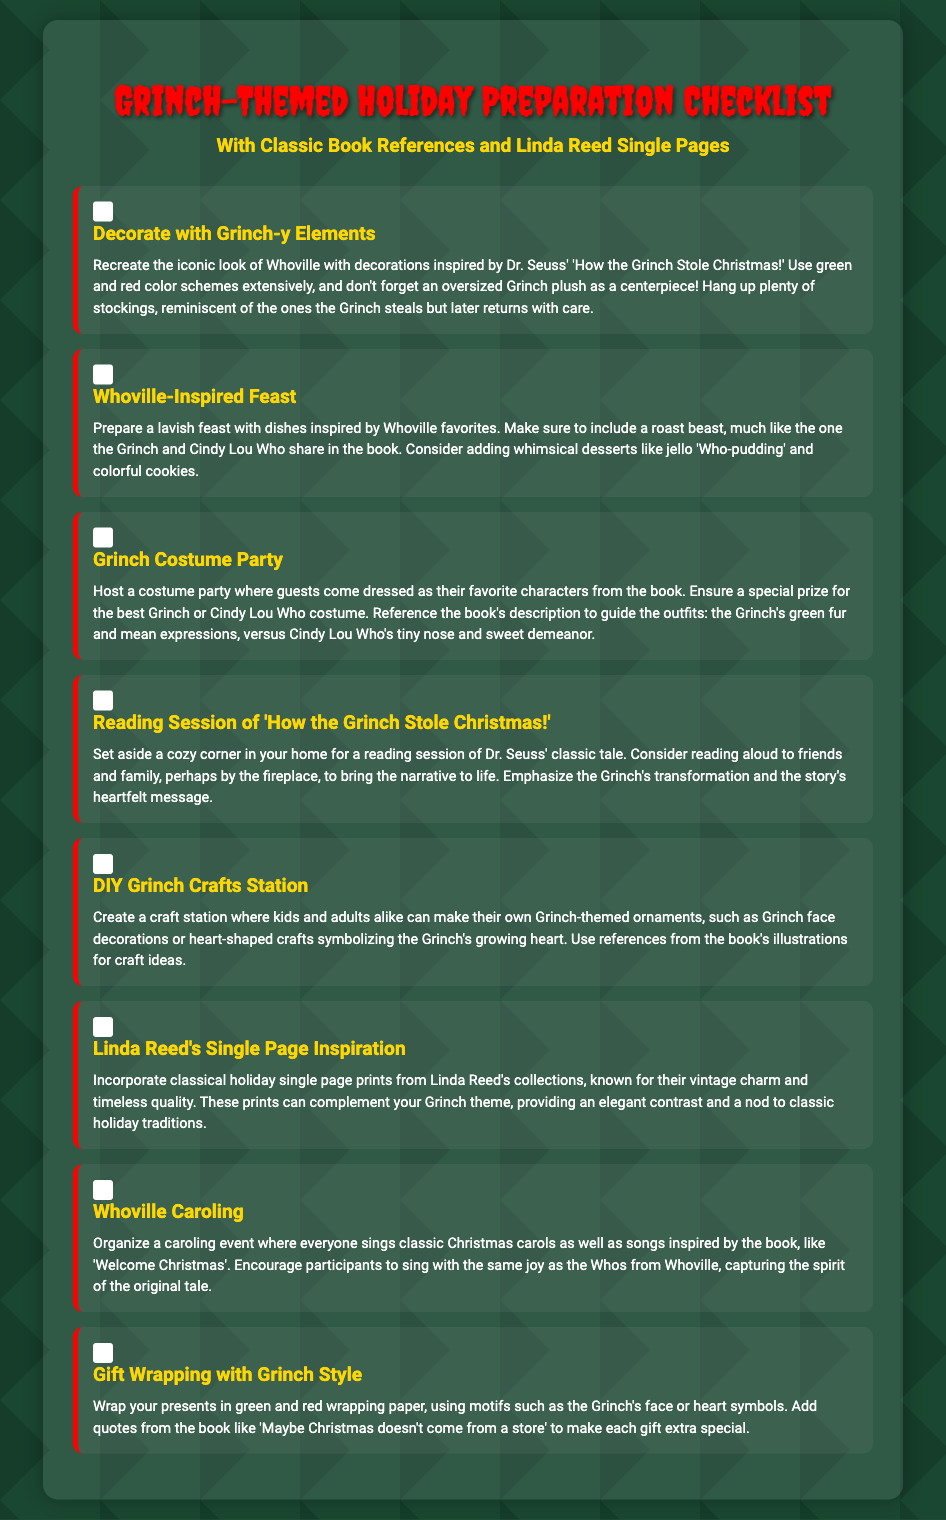What is the title of the document? The title of the document is presented prominently at the top of the page, which is "Grinch-Themed Holiday Preparation Checklist".
Answer: Grinch-Themed Holiday Preparation Checklist How many main checklist items are there? The document lists eight main items in the checklist section, each with its own heading and description.
Answer: 8 What is the color scheme suggested for decorations? The document advises using a specific color scheme for decorations, which prominently includes green and red colors reminiscent of the Grinch.
Answer: Green and red What is one suggested dish for the Whoville-inspired feast? The checklist mentions preparing a 'roast beast' as a must-have dish in the festive feast, inspired by the Grinch's meal with Cindy Lou Who.
Answer: Roast beast What is a suggested activity involving the book "How the Grinch Stole Christmas!"? The document highlights a reading session of the classic story as a cozy activity to engage with friends and family during the holiday preparations.
Answer: Reading session 